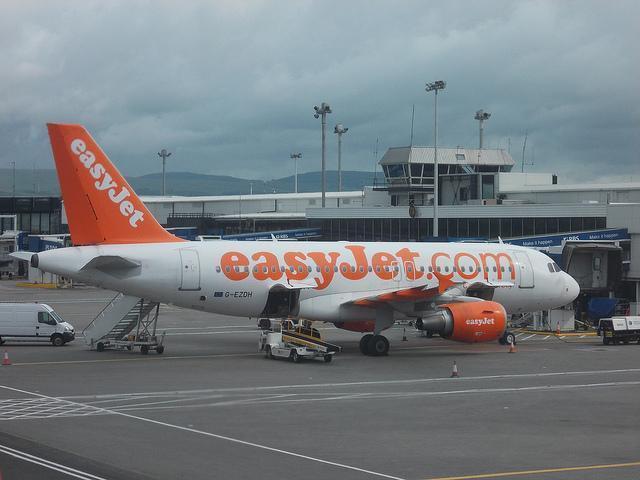How many trucks can you see?
Give a very brief answer. 2. 